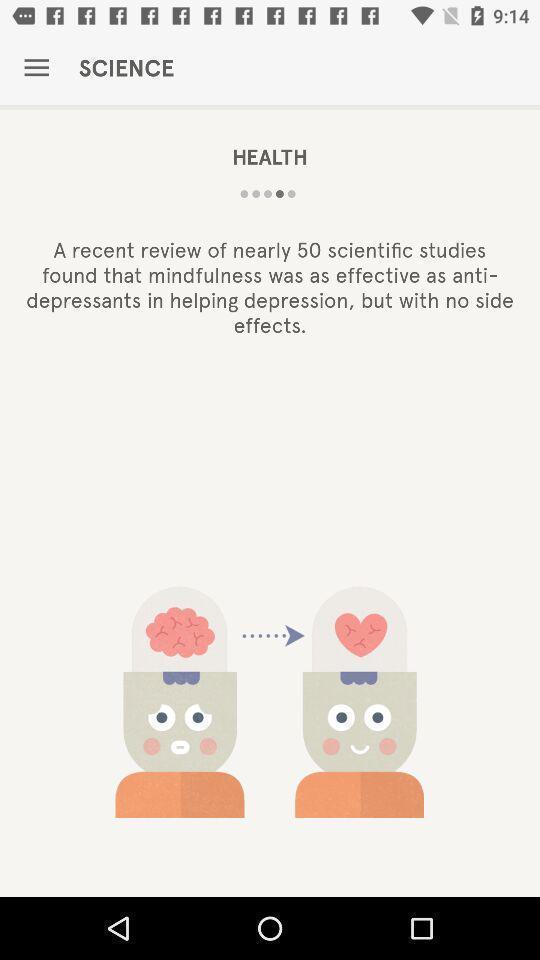Provide a description of this screenshot. Starting page of a health app. 